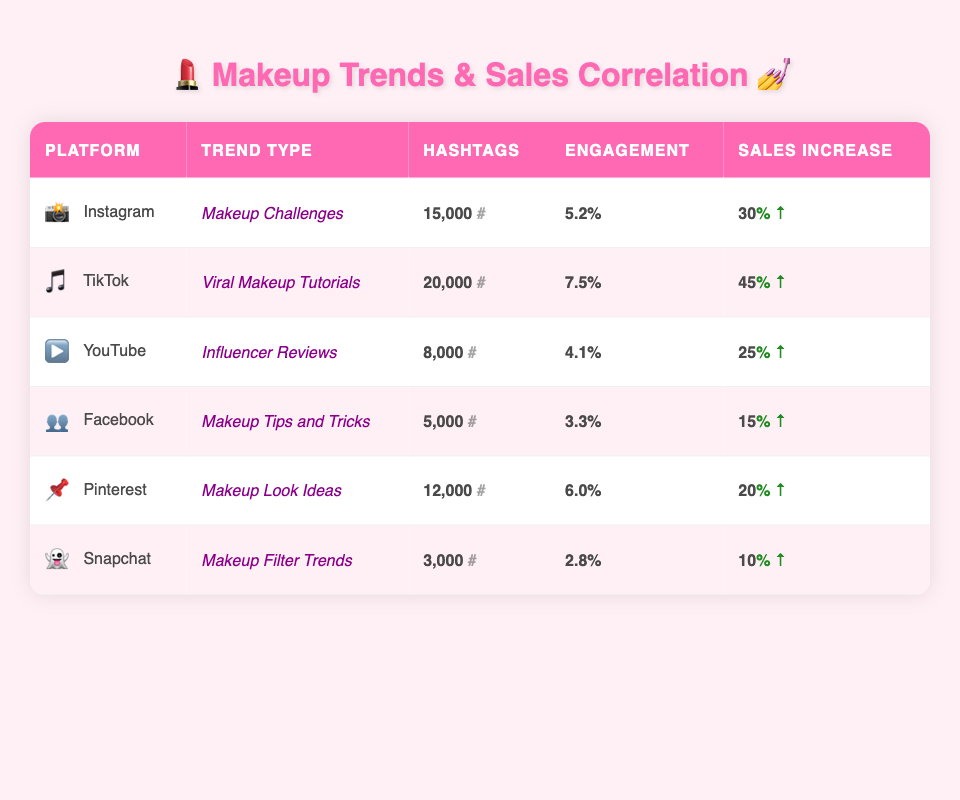What is the maximum monthly sales increase percentage? Looking at the "Monthly Sales Increase" column, the highest value listed is 45, which corresponds to TikTok's Viral Makeup Tutorials.
Answer: 45 What trend type is associated with the highest engagement rate? From the "Engagement" column, TikTok's Viral Makeup Tutorials has the highest engagement rate of 7.5.
Answer: Viral Makeup Tutorials How many hashtags are designated for the Makeup Tips and Tricks trend on Facebook? Referring to the "Designated Hashtags" column for Facebook, it shows 5,000 hashtags associated with the Makeup Tips and Tricks trend.
Answer: 5,000 Is the engagement rate for Instagram’s Makeup Challenges higher than that for Snapchat’s Makeup Filter Trends? The engagement rate for Instagram's Makeup Challenges is 5.2, while for Snapchat’s Makeup Filter Trends is 2.8. Since 5.2 is greater than 2.8, the answer is yes.
Answer: Yes What is the average monthly sales increase percentage for all platforms? To find the average, we first sum the monthly sales increases: 30 (Instagram) + 45 (TikTok) + 25 (YouTube) + 15 (Facebook) + 20 (Pinterest) + 10 (Snapchat) = 145. Then, divide by the number of platforms (6): 145 / 6 = 24.17, rounding down gives us 24.
Answer: 24 Which social media platform has the lowest number of designated hashtags? By comparing the "Designated Hashtags" column, Snapchat has the lowest amount at 3,000 hashtags.
Answer: 3,000 Does the engagement rate correlate positively with monthly sales increase percentage? A positive correlation can be assessed by observing the patterns in both columns. Higher engagement rates appear to align with higher sales increase percentages, especially noticeable with TikTok. Thus, this suggests a positive correlation.
Answer: Yes Which social media platform has the second highest monthly sales increase percentage? The second highest value in the "Monthly Sales Increase" column is associated with Instagram, which has a 30% increase, following TikTok's 45%.
Answer: 30 